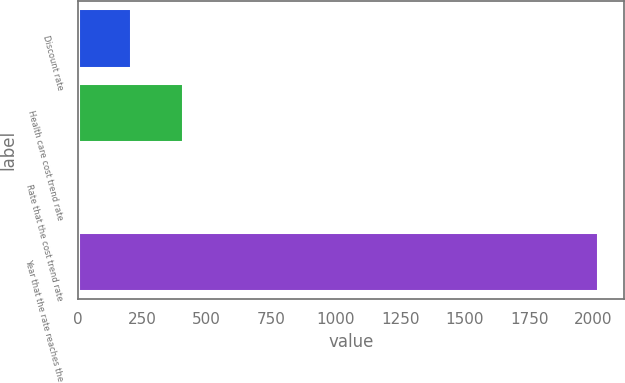Convert chart to OTSL. <chart><loc_0><loc_0><loc_500><loc_500><bar_chart><fcel>Discount rate<fcel>Health care cost trend rate<fcel>Rate that the cost trend rate<fcel>Year that the rate reaches the<nl><fcel>206.2<fcel>407.4<fcel>5<fcel>2017<nl></chart> 